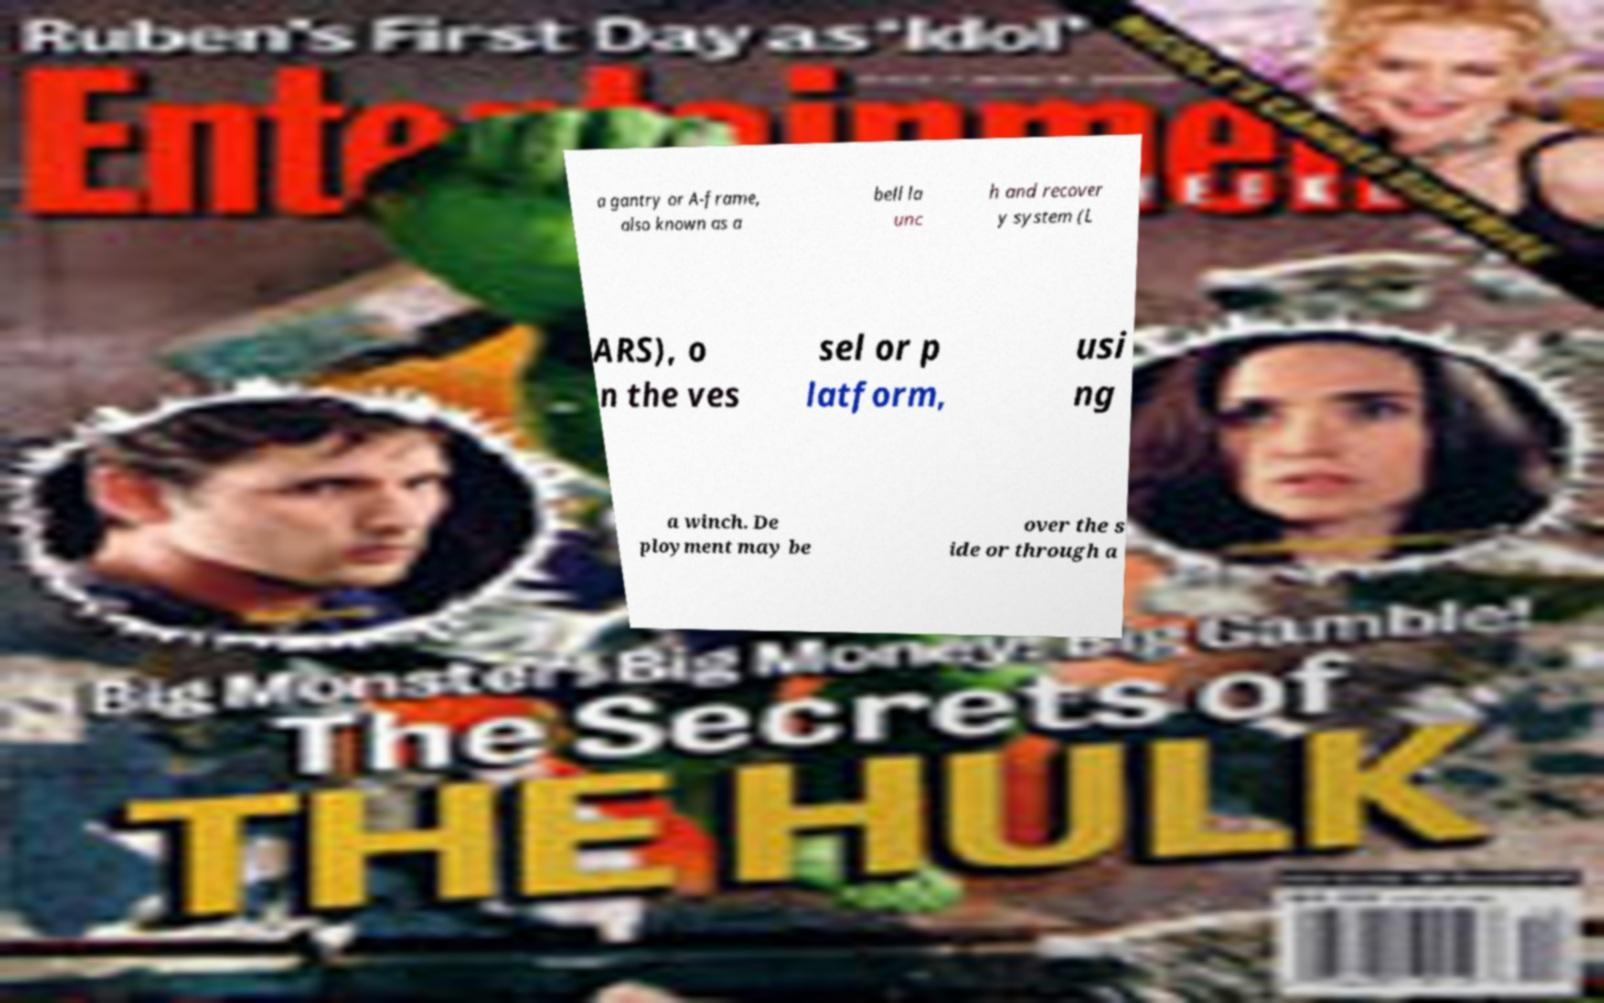Could you assist in decoding the text presented in this image and type it out clearly? a gantry or A-frame, also known as a bell la unc h and recover y system (L ARS), o n the ves sel or p latform, usi ng a winch. De ployment may be over the s ide or through a 